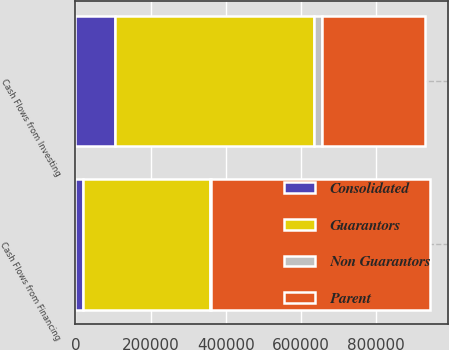<chart> <loc_0><loc_0><loc_500><loc_500><stacked_bar_chart><ecel><fcel>Cash Flows from Investing<fcel>Cash Flows from Financing<nl><fcel>Guarantors<fcel>530160<fcel>335663<nl><fcel>Parent<fcel>274003<fcel>584507<nl><fcel>Non Guarantors<fcel>20799<fcel>2382<nl><fcel>Consolidated<fcel>105221<fcel>21489<nl></chart> 